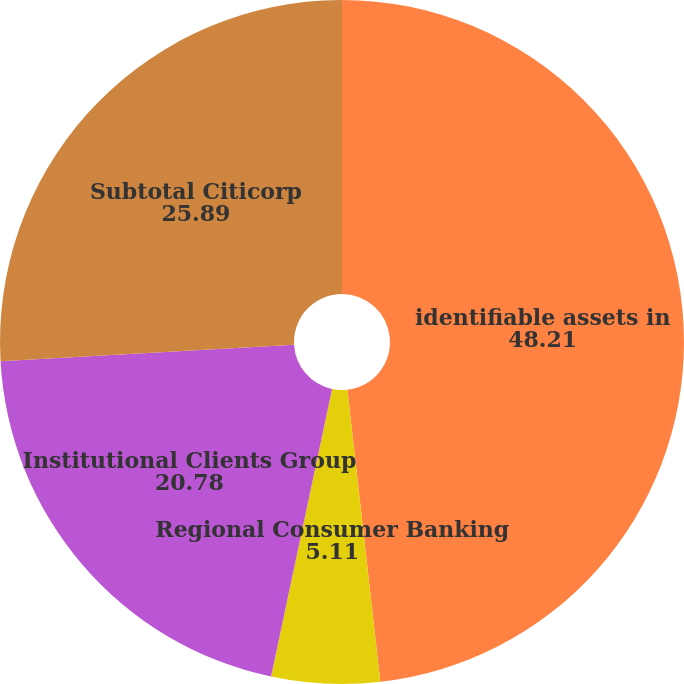Convert chart to OTSL. <chart><loc_0><loc_0><loc_500><loc_500><pie_chart><fcel>identifiable assets in<fcel>Regional Consumer Banking<fcel>Institutional Clients Group<fcel>Subtotal Citicorp<nl><fcel>48.21%<fcel>5.11%<fcel>20.78%<fcel>25.89%<nl></chart> 